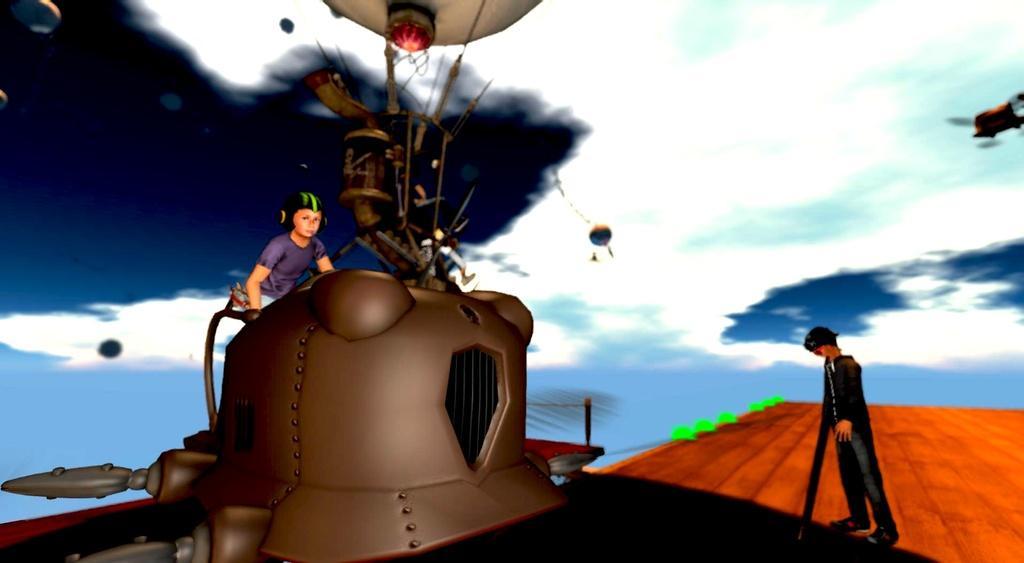Can you describe this image briefly? This image looks like it is animated. To the left, there is a person sitting on the machine. In the background, there are clouds in the sky. At the bottom, there is a floor. 